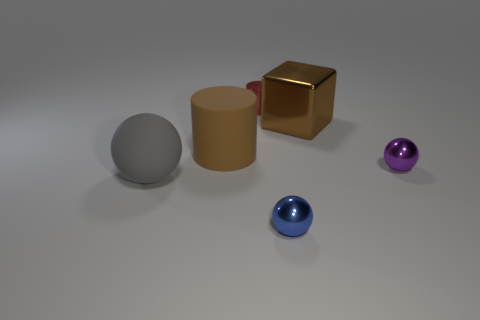Add 1 small purple shiny things. How many objects exist? 7 Subtract all cubes. How many objects are left? 5 Add 2 large gray rubber things. How many large gray rubber things are left? 3 Add 6 large red matte things. How many large red matte things exist? 6 Subtract 0 red spheres. How many objects are left? 6 Subtract all tiny blue shiny objects. Subtract all big brown metal objects. How many objects are left? 4 